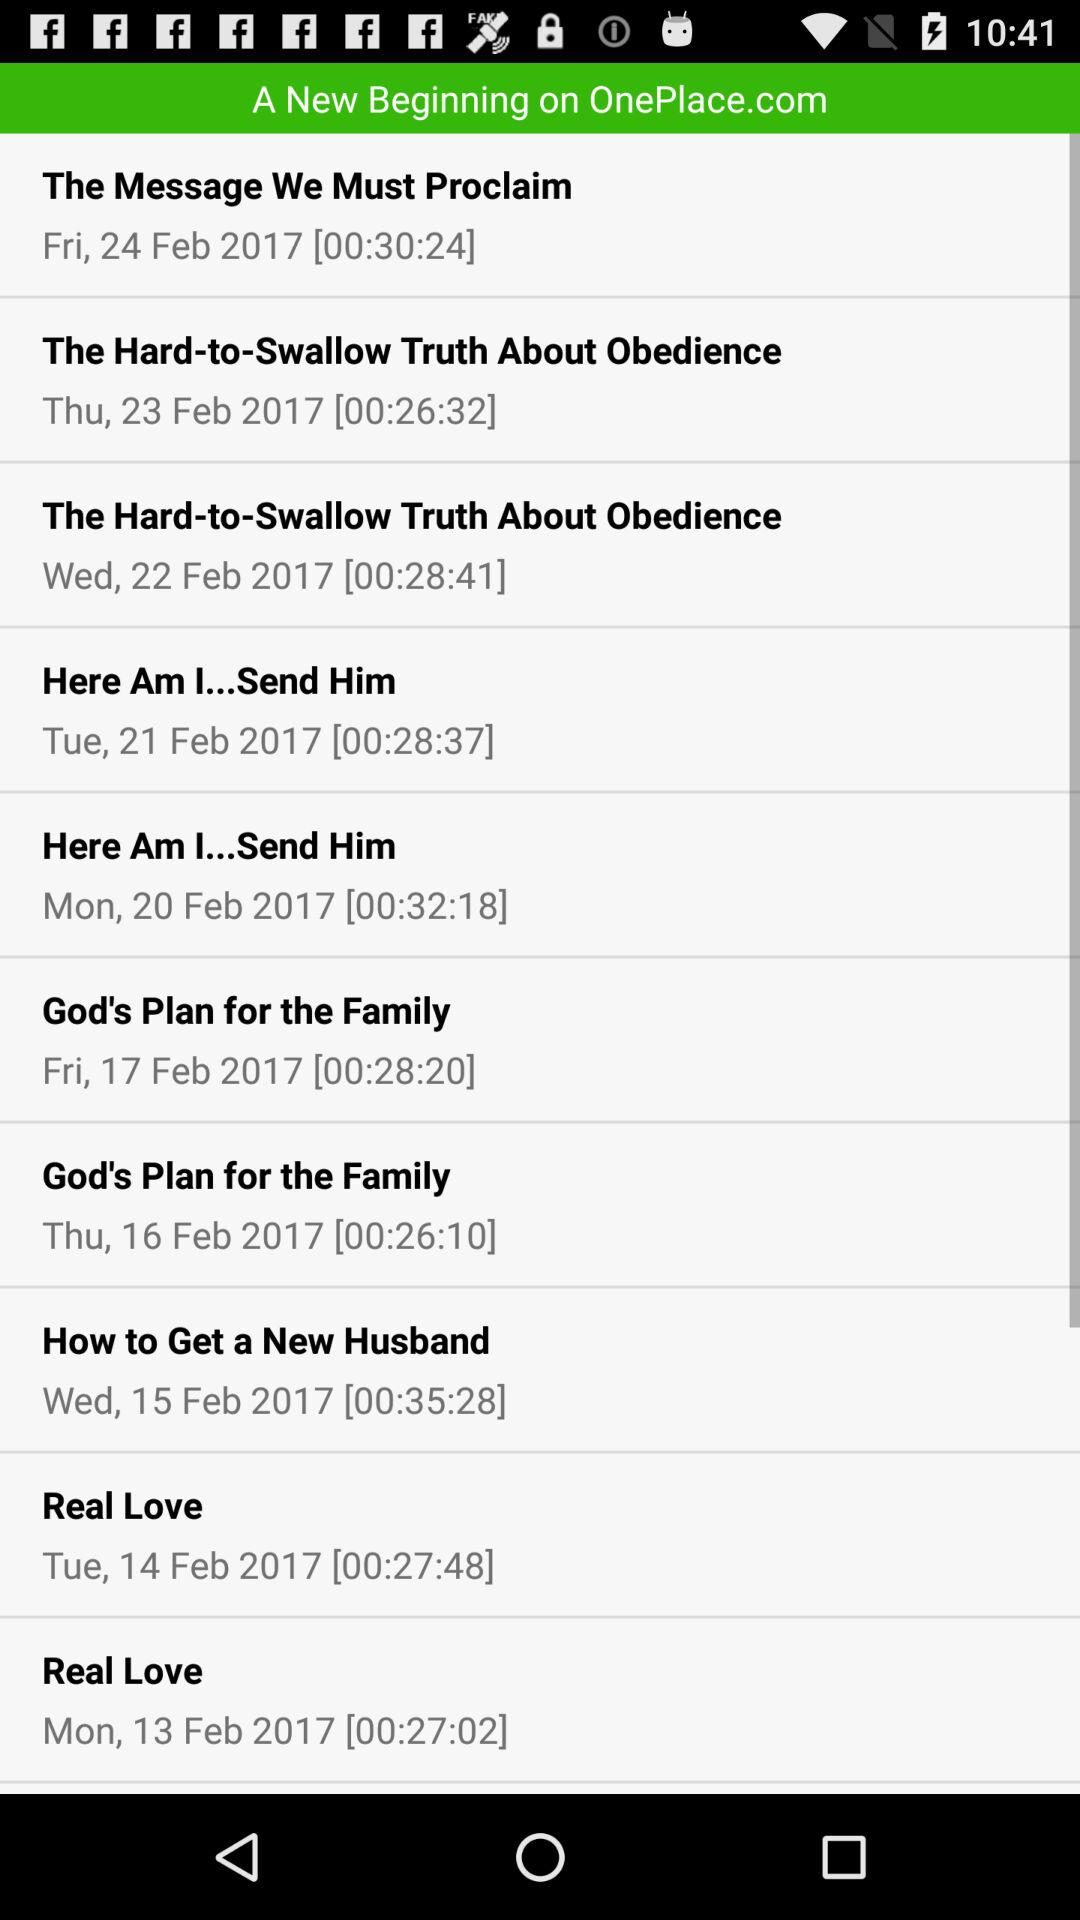What is the date in "Here Am I...Send Him"? The dates are Tuesday, February 21, 2017 and Monday, February 20, 2017. 